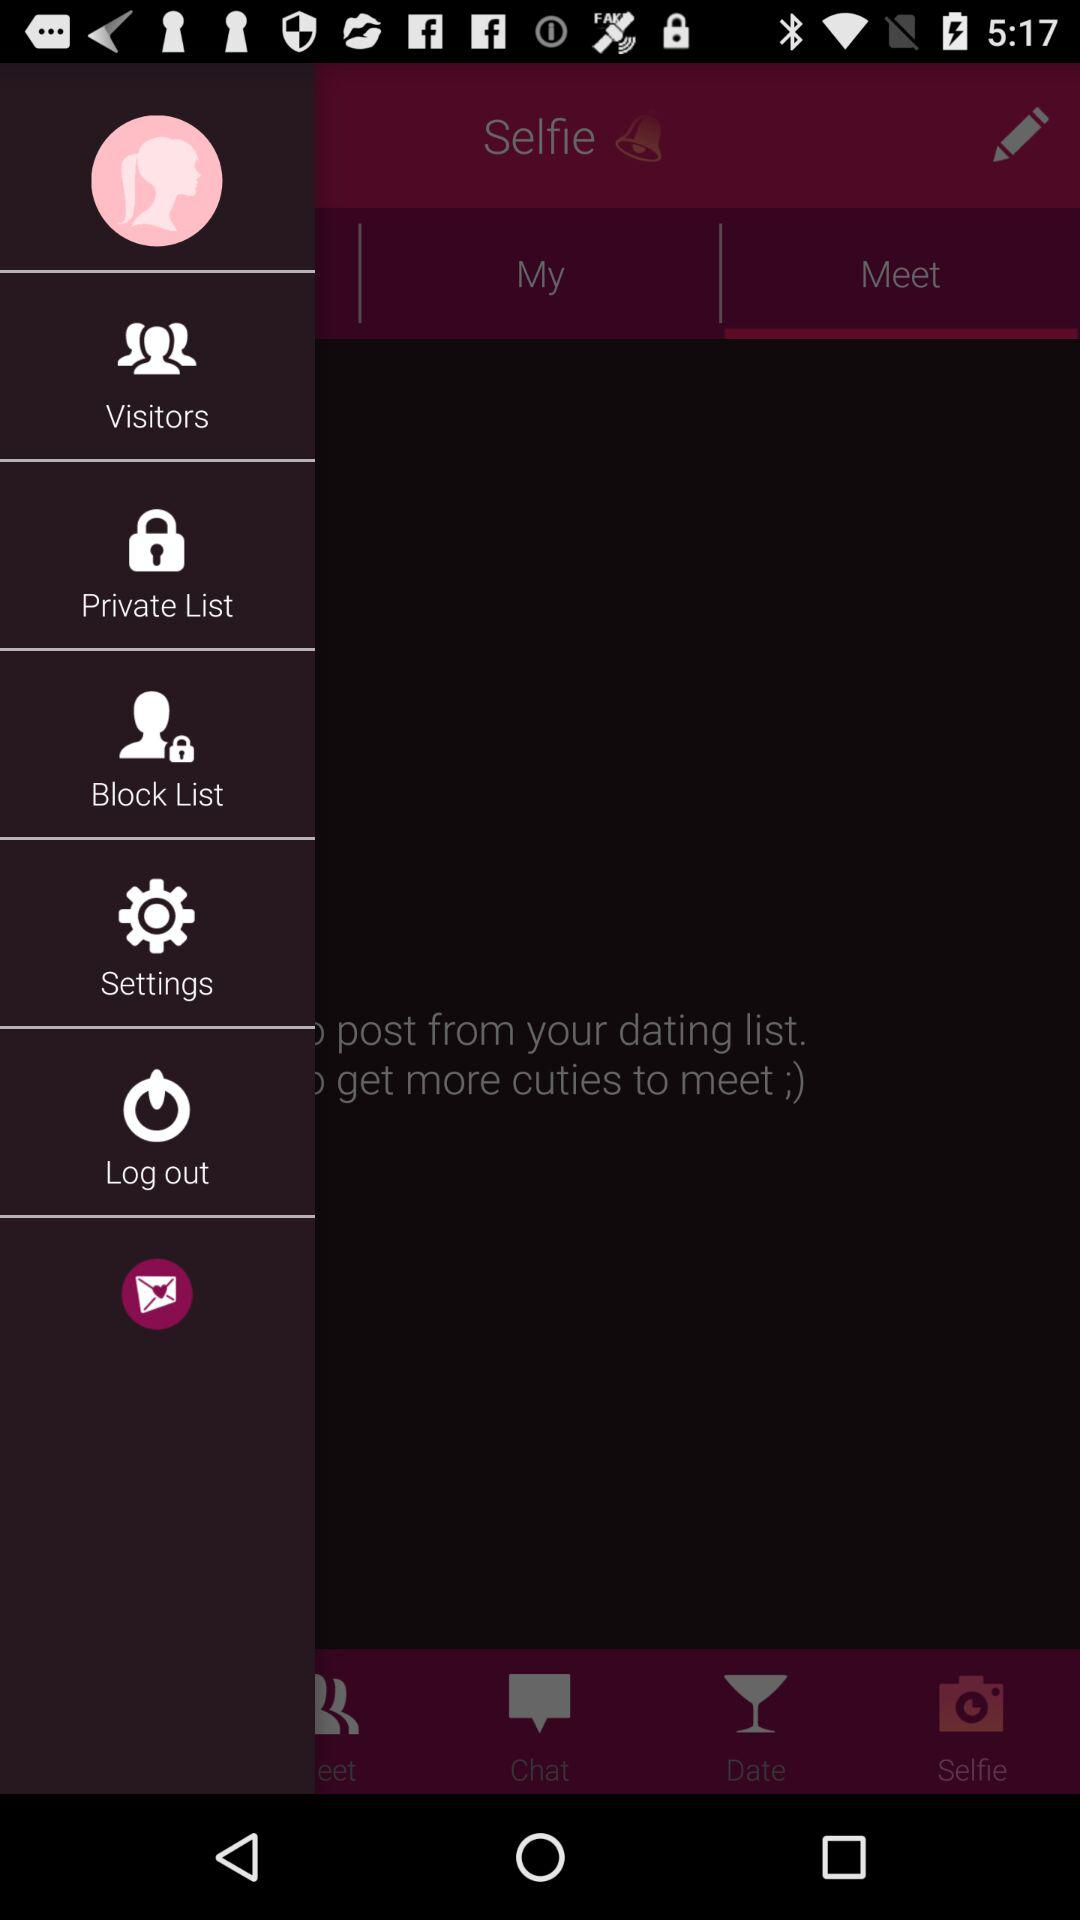What is the app name?
When the provided information is insufficient, respond with <no answer>. <no answer> 